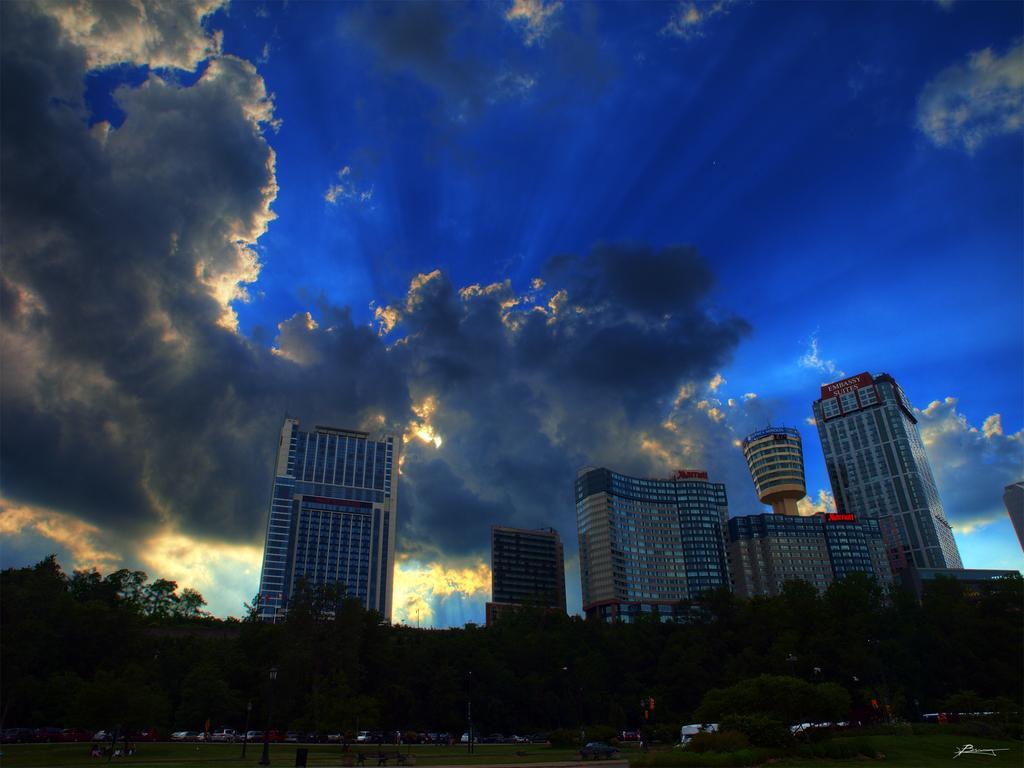Please provide a concise description of this image. As we can see in the image there are buildings, trees, grass, vehicles, sky and clouds. The image is little dark. 